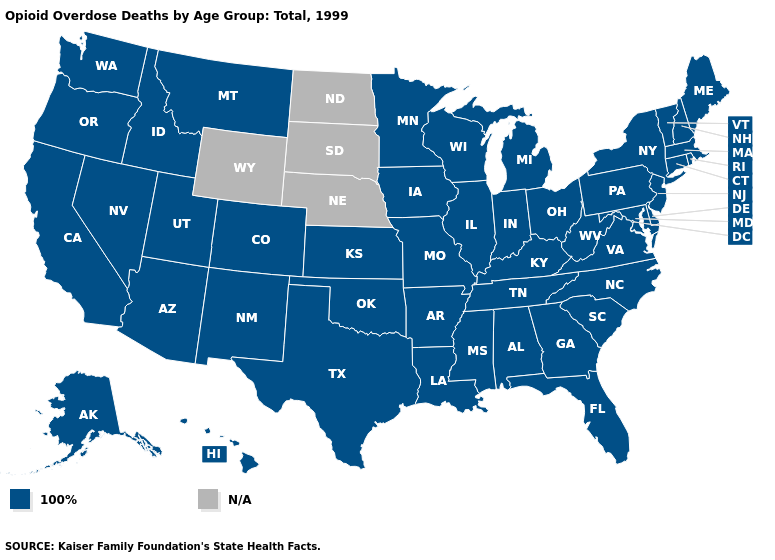Name the states that have a value in the range N/A?
Keep it brief. Nebraska, North Dakota, South Dakota, Wyoming. What is the value of Idaho?
Give a very brief answer. 100%. What is the value of Alaska?
Answer briefly. 100%. Does the map have missing data?
Short answer required. Yes. What is the value of New Jersey?
Give a very brief answer. 100%. Which states have the lowest value in the South?
Write a very short answer. Alabama, Arkansas, Delaware, Florida, Georgia, Kentucky, Louisiana, Maryland, Mississippi, North Carolina, Oklahoma, South Carolina, Tennessee, Texas, Virginia, West Virginia. What is the value of Ohio?
Be succinct. 100%. What is the highest value in the West ?
Be succinct. 100%. What is the highest value in states that border South Dakota?
Concise answer only. 100%. Name the states that have a value in the range N/A?
Quick response, please. Nebraska, North Dakota, South Dakota, Wyoming. Does the first symbol in the legend represent the smallest category?
Short answer required. Yes. What is the value of Nevada?
Answer briefly. 100%. 